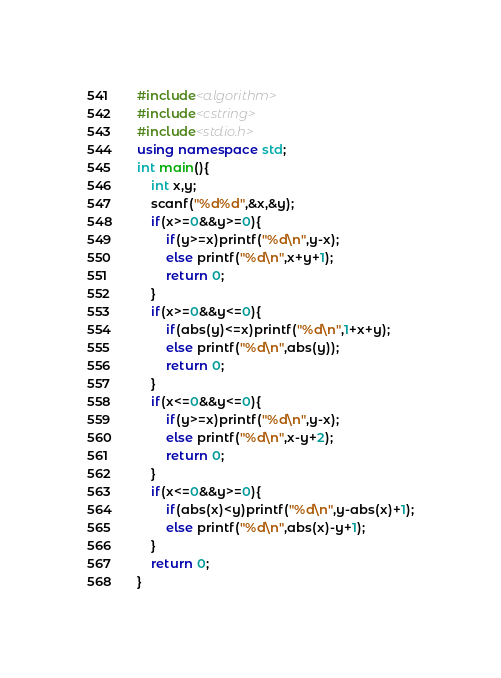Convert code to text. <code><loc_0><loc_0><loc_500><loc_500><_C++_>#include<algorithm>
#include<cstring>
#include<stdio.h>
using namespace std;
int main(){
	int x,y;
	scanf("%d%d",&x,&y);
	if(x>=0&&y>=0){
		if(y>=x)printf("%d\n",y-x);
		else printf("%d\n",x+y+1);
		return 0;
	}
	if(x>=0&&y<=0){
		if(abs(y)<=x)printf("%d\n",1+x+y);
		else printf("%d\n",abs(y));
		return 0;
	}
	if(x<=0&&y<=0){
		if(y>=x)printf("%d\n",y-x);
		else printf("%d\n",x-y+2);
		return 0;	
	}
	if(x<=0&&y>=0){
		if(abs(x)<y)printf("%d\n",y-abs(x)+1);
		else printf("%d\n",abs(x)-y+1);
	}
	return 0;
}
</code> 